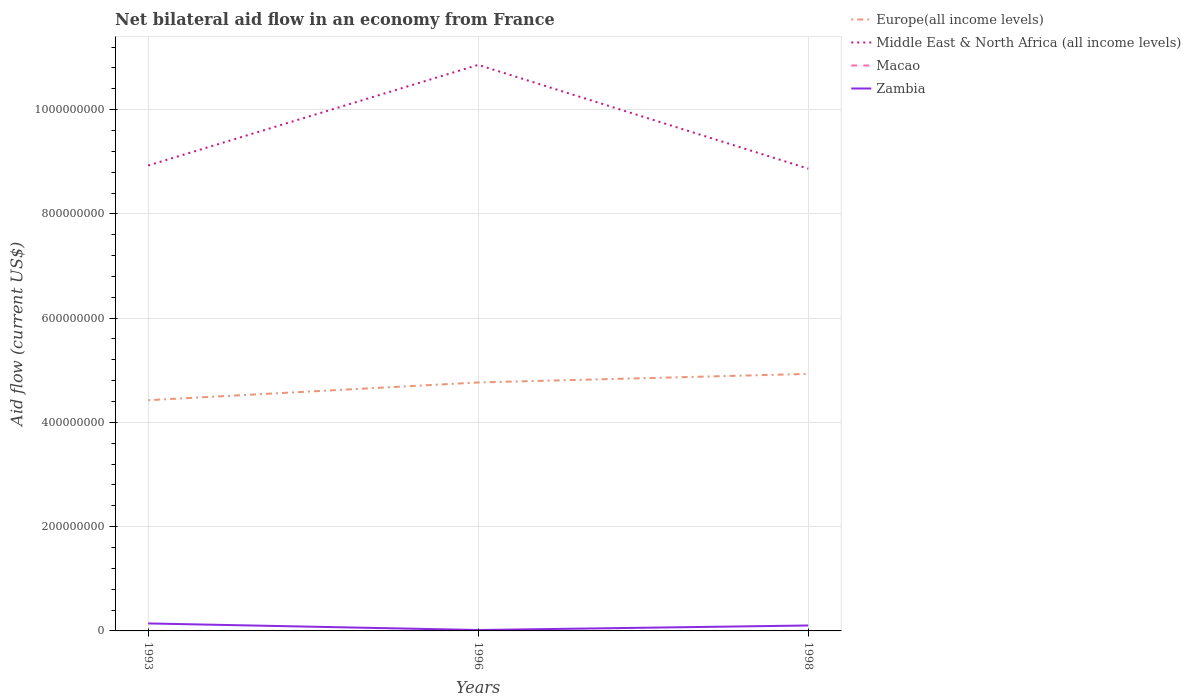Does the line corresponding to Zambia intersect with the line corresponding to Macao?
Provide a short and direct response. No. Across all years, what is the maximum net bilateral aid flow in Middle East & North Africa (all income levels)?
Keep it short and to the point. 8.87e+08. What is the total net bilateral aid flow in Middle East & North Africa (all income levels) in the graph?
Your response must be concise. 6.10e+06. What is the difference between the highest and the second highest net bilateral aid flow in Zambia?
Provide a short and direct response. 1.26e+07. What is the difference between the highest and the lowest net bilateral aid flow in Europe(all income levels)?
Give a very brief answer. 2. Is the net bilateral aid flow in Middle East & North Africa (all income levels) strictly greater than the net bilateral aid flow in Zambia over the years?
Your response must be concise. No. How many years are there in the graph?
Offer a very short reply. 3. What is the difference between two consecutive major ticks on the Y-axis?
Ensure brevity in your answer.  2.00e+08. Does the graph contain grids?
Ensure brevity in your answer.  Yes. Where does the legend appear in the graph?
Your response must be concise. Top right. What is the title of the graph?
Your answer should be compact. Net bilateral aid flow in an economy from France. What is the label or title of the X-axis?
Give a very brief answer. Years. What is the label or title of the Y-axis?
Offer a very short reply. Aid flow (current US$). What is the Aid flow (current US$) of Europe(all income levels) in 1993?
Offer a terse response. 4.43e+08. What is the Aid flow (current US$) in Middle East & North Africa (all income levels) in 1993?
Keep it short and to the point. 8.93e+08. What is the Aid flow (current US$) of Macao in 1993?
Your answer should be compact. 10000. What is the Aid flow (current US$) of Zambia in 1993?
Offer a terse response. 1.44e+07. What is the Aid flow (current US$) in Europe(all income levels) in 1996?
Offer a terse response. 4.77e+08. What is the Aid flow (current US$) in Middle East & North Africa (all income levels) in 1996?
Your response must be concise. 1.09e+09. What is the Aid flow (current US$) of Macao in 1996?
Provide a succinct answer. 2.00e+04. What is the Aid flow (current US$) of Zambia in 1996?
Offer a very short reply. 1.73e+06. What is the Aid flow (current US$) in Europe(all income levels) in 1998?
Give a very brief answer. 4.93e+08. What is the Aid flow (current US$) in Middle East & North Africa (all income levels) in 1998?
Your response must be concise. 8.87e+08. What is the Aid flow (current US$) of Zambia in 1998?
Provide a short and direct response. 1.04e+07. Across all years, what is the maximum Aid flow (current US$) of Europe(all income levels)?
Ensure brevity in your answer.  4.93e+08. Across all years, what is the maximum Aid flow (current US$) in Middle East & North Africa (all income levels)?
Keep it short and to the point. 1.09e+09. Across all years, what is the maximum Aid flow (current US$) in Macao?
Provide a short and direct response. 2.00e+04. Across all years, what is the maximum Aid flow (current US$) of Zambia?
Your response must be concise. 1.44e+07. Across all years, what is the minimum Aid flow (current US$) of Europe(all income levels)?
Provide a short and direct response. 4.43e+08. Across all years, what is the minimum Aid flow (current US$) in Middle East & North Africa (all income levels)?
Ensure brevity in your answer.  8.87e+08. Across all years, what is the minimum Aid flow (current US$) of Zambia?
Your answer should be compact. 1.73e+06. What is the total Aid flow (current US$) in Europe(all income levels) in the graph?
Keep it short and to the point. 1.41e+09. What is the total Aid flow (current US$) in Middle East & North Africa (all income levels) in the graph?
Make the answer very short. 2.87e+09. What is the total Aid flow (current US$) in Zambia in the graph?
Your response must be concise. 2.65e+07. What is the difference between the Aid flow (current US$) of Europe(all income levels) in 1993 and that in 1996?
Your answer should be very brief. -3.40e+07. What is the difference between the Aid flow (current US$) of Middle East & North Africa (all income levels) in 1993 and that in 1996?
Your response must be concise. -1.93e+08. What is the difference between the Aid flow (current US$) in Zambia in 1993 and that in 1996?
Keep it short and to the point. 1.26e+07. What is the difference between the Aid flow (current US$) in Europe(all income levels) in 1993 and that in 1998?
Give a very brief answer. -5.04e+07. What is the difference between the Aid flow (current US$) of Middle East & North Africa (all income levels) in 1993 and that in 1998?
Offer a very short reply. 6.10e+06. What is the difference between the Aid flow (current US$) of Zambia in 1993 and that in 1998?
Your answer should be very brief. 3.92e+06. What is the difference between the Aid flow (current US$) of Europe(all income levels) in 1996 and that in 1998?
Provide a short and direct response. -1.64e+07. What is the difference between the Aid flow (current US$) in Middle East & North Africa (all income levels) in 1996 and that in 1998?
Ensure brevity in your answer.  1.99e+08. What is the difference between the Aid flow (current US$) of Zambia in 1996 and that in 1998?
Make the answer very short. -8.70e+06. What is the difference between the Aid flow (current US$) of Europe(all income levels) in 1993 and the Aid flow (current US$) of Middle East & North Africa (all income levels) in 1996?
Offer a very short reply. -6.43e+08. What is the difference between the Aid flow (current US$) of Europe(all income levels) in 1993 and the Aid flow (current US$) of Macao in 1996?
Your answer should be very brief. 4.43e+08. What is the difference between the Aid flow (current US$) of Europe(all income levels) in 1993 and the Aid flow (current US$) of Zambia in 1996?
Your response must be concise. 4.41e+08. What is the difference between the Aid flow (current US$) of Middle East & North Africa (all income levels) in 1993 and the Aid flow (current US$) of Macao in 1996?
Provide a short and direct response. 8.93e+08. What is the difference between the Aid flow (current US$) of Middle East & North Africa (all income levels) in 1993 and the Aid flow (current US$) of Zambia in 1996?
Give a very brief answer. 8.91e+08. What is the difference between the Aid flow (current US$) of Macao in 1993 and the Aid flow (current US$) of Zambia in 1996?
Provide a short and direct response. -1.72e+06. What is the difference between the Aid flow (current US$) in Europe(all income levels) in 1993 and the Aid flow (current US$) in Middle East & North Africa (all income levels) in 1998?
Your answer should be compact. -4.44e+08. What is the difference between the Aid flow (current US$) in Europe(all income levels) in 1993 and the Aid flow (current US$) in Macao in 1998?
Give a very brief answer. 4.43e+08. What is the difference between the Aid flow (current US$) in Europe(all income levels) in 1993 and the Aid flow (current US$) in Zambia in 1998?
Ensure brevity in your answer.  4.32e+08. What is the difference between the Aid flow (current US$) of Middle East & North Africa (all income levels) in 1993 and the Aid flow (current US$) of Macao in 1998?
Ensure brevity in your answer.  8.93e+08. What is the difference between the Aid flow (current US$) in Middle East & North Africa (all income levels) in 1993 and the Aid flow (current US$) in Zambia in 1998?
Provide a succinct answer. 8.82e+08. What is the difference between the Aid flow (current US$) of Macao in 1993 and the Aid flow (current US$) of Zambia in 1998?
Your answer should be very brief. -1.04e+07. What is the difference between the Aid flow (current US$) of Europe(all income levels) in 1996 and the Aid flow (current US$) of Middle East & North Africa (all income levels) in 1998?
Give a very brief answer. -4.10e+08. What is the difference between the Aid flow (current US$) of Europe(all income levels) in 1996 and the Aid flow (current US$) of Macao in 1998?
Offer a very short reply. 4.77e+08. What is the difference between the Aid flow (current US$) of Europe(all income levels) in 1996 and the Aid flow (current US$) of Zambia in 1998?
Provide a succinct answer. 4.66e+08. What is the difference between the Aid flow (current US$) of Middle East & North Africa (all income levels) in 1996 and the Aid flow (current US$) of Macao in 1998?
Offer a terse response. 1.09e+09. What is the difference between the Aid flow (current US$) of Middle East & North Africa (all income levels) in 1996 and the Aid flow (current US$) of Zambia in 1998?
Provide a short and direct response. 1.08e+09. What is the difference between the Aid flow (current US$) of Macao in 1996 and the Aid flow (current US$) of Zambia in 1998?
Give a very brief answer. -1.04e+07. What is the average Aid flow (current US$) in Europe(all income levels) per year?
Give a very brief answer. 4.71e+08. What is the average Aid flow (current US$) of Middle East & North Africa (all income levels) per year?
Keep it short and to the point. 9.55e+08. What is the average Aid flow (current US$) in Macao per year?
Ensure brevity in your answer.  1.33e+04. What is the average Aid flow (current US$) in Zambia per year?
Your answer should be compact. 8.84e+06. In the year 1993, what is the difference between the Aid flow (current US$) of Europe(all income levels) and Aid flow (current US$) of Middle East & North Africa (all income levels)?
Provide a succinct answer. -4.50e+08. In the year 1993, what is the difference between the Aid flow (current US$) in Europe(all income levels) and Aid flow (current US$) in Macao?
Give a very brief answer. 4.43e+08. In the year 1993, what is the difference between the Aid flow (current US$) in Europe(all income levels) and Aid flow (current US$) in Zambia?
Make the answer very short. 4.28e+08. In the year 1993, what is the difference between the Aid flow (current US$) in Middle East & North Africa (all income levels) and Aid flow (current US$) in Macao?
Provide a short and direct response. 8.93e+08. In the year 1993, what is the difference between the Aid flow (current US$) in Middle East & North Africa (all income levels) and Aid flow (current US$) in Zambia?
Make the answer very short. 8.79e+08. In the year 1993, what is the difference between the Aid flow (current US$) in Macao and Aid flow (current US$) in Zambia?
Your response must be concise. -1.43e+07. In the year 1996, what is the difference between the Aid flow (current US$) in Europe(all income levels) and Aid flow (current US$) in Middle East & North Africa (all income levels)?
Make the answer very short. -6.09e+08. In the year 1996, what is the difference between the Aid flow (current US$) in Europe(all income levels) and Aid flow (current US$) in Macao?
Ensure brevity in your answer.  4.77e+08. In the year 1996, what is the difference between the Aid flow (current US$) in Europe(all income levels) and Aid flow (current US$) in Zambia?
Your response must be concise. 4.75e+08. In the year 1996, what is the difference between the Aid flow (current US$) in Middle East & North Africa (all income levels) and Aid flow (current US$) in Macao?
Provide a succinct answer. 1.09e+09. In the year 1996, what is the difference between the Aid flow (current US$) of Middle East & North Africa (all income levels) and Aid flow (current US$) of Zambia?
Make the answer very short. 1.08e+09. In the year 1996, what is the difference between the Aid flow (current US$) of Macao and Aid flow (current US$) of Zambia?
Give a very brief answer. -1.71e+06. In the year 1998, what is the difference between the Aid flow (current US$) in Europe(all income levels) and Aid flow (current US$) in Middle East & North Africa (all income levels)?
Your answer should be very brief. -3.94e+08. In the year 1998, what is the difference between the Aid flow (current US$) in Europe(all income levels) and Aid flow (current US$) in Macao?
Offer a terse response. 4.93e+08. In the year 1998, what is the difference between the Aid flow (current US$) of Europe(all income levels) and Aid flow (current US$) of Zambia?
Ensure brevity in your answer.  4.83e+08. In the year 1998, what is the difference between the Aid flow (current US$) in Middle East & North Africa (all income levels) and Aid flow (current US$) in Macao?
Provide a short and direct response. 8.87e+08. In the year 1998, what is the difference between the Aid flow (current US$) in Middle East & North Africa (all income levels) and Aid flow (current US$) in Zambia?
Ensure brevity in your answer.  8.76e+08. In the year 1998, what is the difference between the Aid flow (current US$) in Macao and Aid flow (current US$) in Zambia?
Keep it short and to the point. -1.04e+07. What is the ratio of the Aid flow (current US$) of Europe(all income levels) in 1993 to that in 1996?
Provide a short and direct response. 0.93. What is the ratio of the Aid flow (current US$) of Middle East & North Africa (all income levels) in 1993 to that in 1996?
Provide a succinct answer. 0.82. What is the ratio of the Aid flow (current US$) of Zambia in 1993 to that in 1996?
Give a very brief answer. 8.29. What is the ratio of the Aid flow (current US$) of Europe(all income levels) in 1993 to that in 1998?
Give a very brief answer. 0.9. What is the ratio of the Aid flow (current US$) in Zambia in 1993 to that in 1998?
Offer a terse response. 1.38. What is the ratio of the Aid flow (current US$) of Europe(all income levels) in 1996 to that in 1998?
Your response must be concise. 0.97. What is the ratio of the Aid flow (current US$) in Middle East & North Africa (all income levels) in 1996 to that in 1998?
Offer a terse response. 1.22. What is the ratio of the Aid flow (current US$) in Zambia in 1996 to that in 1998?
Give a very brief answer. 0.17. What is the difference between the highest and the second highest Aid flow (current US$) of Europe(all income levels)?
Provide a short and direct response. 1.64e+07. What is the difference between the highest and the second highest Aid flow (current US$) of Middle East & North Africa (all income levels)?
Ensure brevity in your answer.  1.93e+08. What is the difference between the highest and the second highest Aid flow (current US$) of Macao?
Your response must be concise. 10000. What is the difference between the highest and the second highest Aid flow (current US$) in Zambia?
Give a very brief answer. 3.92e+06. What is the difference between the highest and the lowest Aid flow (current US$) in Europe(all income levels)?
Give a very brief answer. 5.04e+07. What is the difference between the highest and the lowest Aid flow (current US$) in Middle East & North Africa (all income levels)?
Provide a short and direct response. 1.99e+08. What is the difference between the highest and the lowest Aid flow (current US$) of Macao?
Make the answer very short. 10000. What is the difference between the highest and the lowest Aid flow (current US$) of Zambia?
Make the answer very short. 1.26e+07. 